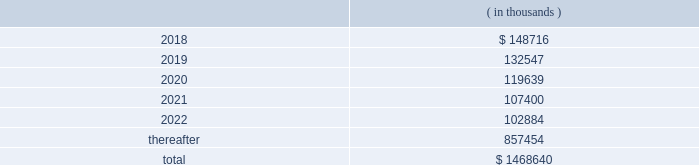Hollyfrontier corporation notes to consolidated financial statements continued .
Transportation and storage costs incurred under these agreements totaled $ 140.5 million , $ 135.1 million and $ 137.7 million for the years ended december 31 , 2017 , 2016 and 2015 , respectively .
These amounts do not include contractual commitments under our long-term transportation agreements with hep , as all transactions with hep are eliminated in these consolidated financial statements .
We have a crude oil supply contract that requires the supplier to deliver a specified volume of crude oil or pay a shortfall fee for the difference in the actual barrels delivered to us less the specified barrels per the supply contract .
For the contract year ended august 31 , 2017 , the actual number of barrels delivered to us was substantially less than the specified barrels , and we recorded a reduction to cost of goods sold and accumulated a shortfall fee receivable of $ 26.0 million during this period .
In september 2017 , the supplier notified us they are disputing the shortfall fee owed and in october 2017 notified us of their demand for arbitration .
We offset the receivable with payments of invoices for deliveries of crude oil received subsequent to august 31 , 2017 , which is permitted under the supply contract .
We believe the disputes and claims made by the supplier are without merit .
In march , 2006 , a subsidiary of ours sold the assets of montana refining company under an asset purchase agreement ( 201capa 201d ) .
Calumet montana refining llc , the current owner of the assets , has submitted requests for reimbursement of approximately $ 20.0 million pursuant to contractual indemnity provisions under the apa for various costs incurred , as well as additional claims related to environmental matters .
We have rejected most of the claims for payment , and this matter is scheduled for arbitration beginning in july 2018 .
We have accrued the costs we believe are owed pursuant to the apa , and we estimate that any reasonably possible losses beyond the amounts accrued are not material .
Note 20 : segment information effective fourth quarter of 2017 , we revised our reportable segments to align with certain changes in how our chief operating decision maker manages and allocates resources to our business .
Accordingly , our tulsa refineries 2019 lubricants operations , previously reported in the refining segment , are now combined with the operations of our petro-canada lubricants business ( acquired february 1 , 2017 ) and reported in the lubricants and specialty products segment .
Our prior period segment information has been retrospectively adjusted to reflect our current segment presentation .
Our operations are organized into three reportable segments , refining , lubricants and specialty products and hep .
Our operations that are not included in the refining , lubricants and specialty products and hep segments are included in corporate and other .
Intersegment transactions are eliminated in our consolidated financial statements and are included in eliminations .
Corporate and other and eliminations are aggregated and presented under corporate , other and eliminations column .
The refining segment represents the operations of the el dorado , tulsa , navajo , cheyenne and woods cross refineries and hfc asphalt ( aggregated as a reportable segment ) .
Refining activities involve the purchase and refining of crude oil and wholesale and branded marketing of refined products , such as gasoline , diesel fuel and jet fuel .
These petroleum products are primarily marketed in the mid-continent , southwest and rocky mountain regions of the united states .
Hfc asphalt operates various asphalt terminals in arizona , new mexico and oklahoma. .
What were total transportation and storage costs incurred under these agreements for the years ended december 31 , 2017 , 2016 and 2015? 
Computations: ((140.5 + 135.1) + 137.7)
Answer: 413.3. 